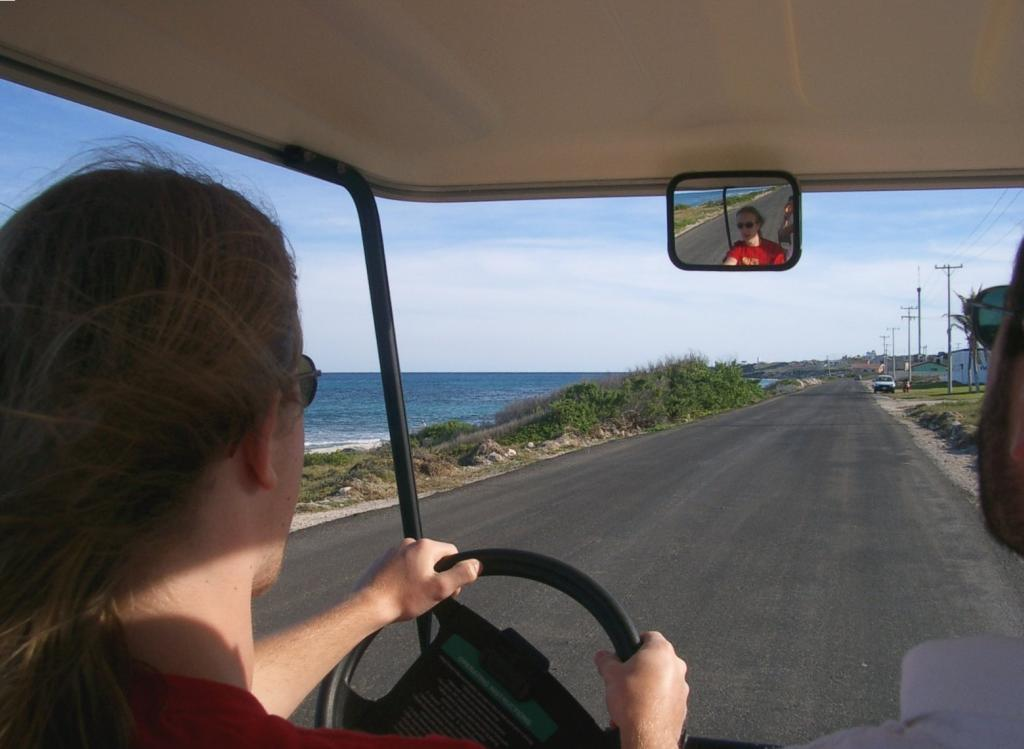Who is the main subject in the image? There is a woman in the image. What is the woman doing in the image? The woman is riding a vehicle. Where is the vehicle located in the image? The vehicle is on the roadside. What type of natural elements can be seen in the image? There are plants and water visible in the image. How many knots are tied in the woman's hair in the image? There is no information about the woman's hair or any knots in the image. What items are on the woman's list in the image? There is no list or any reference to a list in the image. 